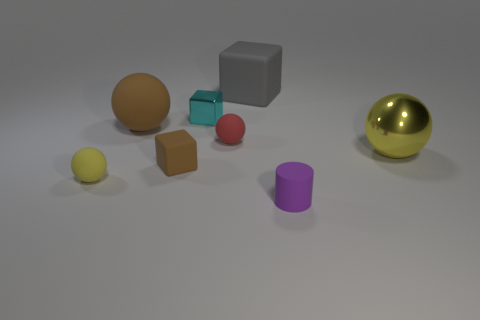Are the sphere right of the small red rubber ball and the purple object made of the same material?
Your response must be concise. No. Is there anything else that is the same size as the purple object?
Provide a succinct answer. Yes. The yellow thing that is on the right side of the purple thing right of the big matte ball is made of what material?
Your answer should be very brief. Metal. Is the number of small metallic objects that are in front of the big yellow sphere greater than the number of cyan objects to the right of the small purple cylinder?
Ensure brevity in your answer.  No. The purple matte thing has what size?
Give a very brief answer. Small. Do the small matte ball right of the small yellow rubber object and the rubber cylinder have the same color?
Your response must be concise. No. Is there anything else that has the same shape as the gray rubber object?
Provide a short and direct response. Yes. There is a matte block to the right of the small shiny cube; are there any large gray things that are on the left side of it?
Your response must be concise. No. Are there fewer red objects that are behind the tiny red sphere than yellow rubber spheres to the right of the large yellow metallic object?
Offer a terse response. No. How big is the matte object that is in front of the yellow ball that is in front of the sphere that is right of the tiny purple cylinder?
Make the answer very short. Small. 